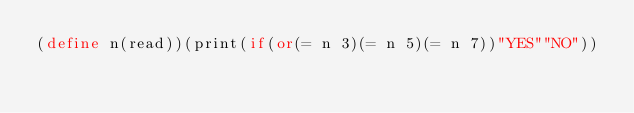Convert code to text. <code><loc_0><loc_0><loc_500><loc_500><_Scheme_>(define n(read))(print(if(or(= n 3)(= n 5)(= n 7))"YES""NO"))</code> 